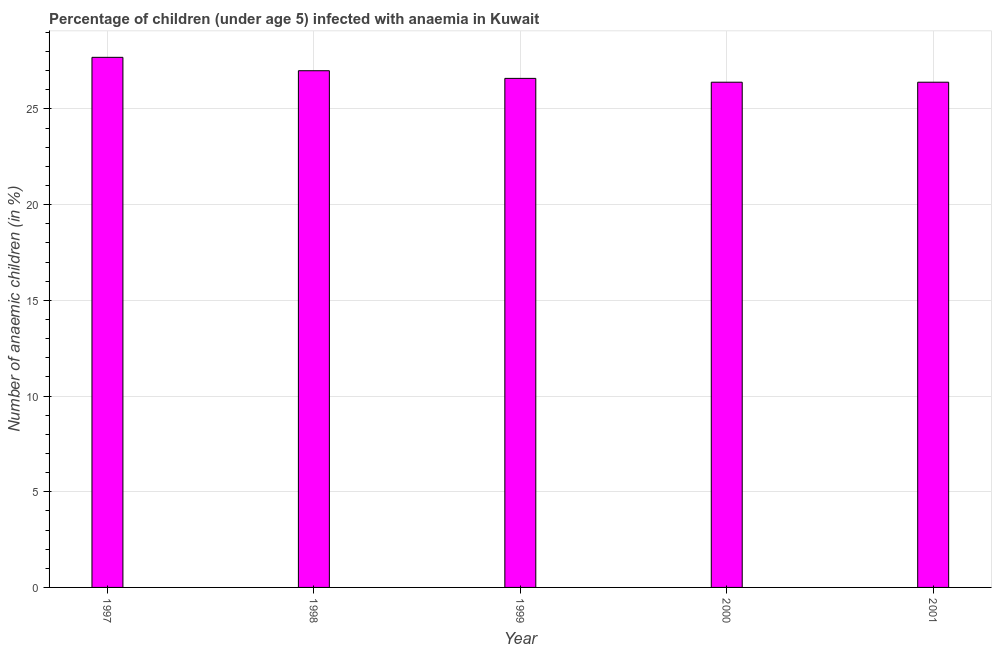Does the graph contain grids?
Give a very brief answer. Yes. What is the title of the graph?
Offer a terse response. Percentage of children (under age 5) infected with anaemia in Kuwait. What is the label or title of the Y-axis?
Your response must be concise. Number of anaemic children (in %). What is the number of anaemic children in 2000?
Offer a very short reply. 26.4. Across all years, what is the maximum number of anaemic children?
Give a very brief answer. 27.7. Across all years, what is the minimum number of anaemic children?
Your answer should be compact. 26.4. In which year was the number of anaemic children minimum?
Make the answer very short. 2000. What is the sum of the number of anaemic children?
Provide a succinct answer. 134.1. What is the difference between the number of anaemic children in 1997 and 1998?
Ensure brevity in your answer.  0.7. What is the average number of anaemic children per year?
Your answer should be compact. 26.82. What is the median number of anaemic children?
Make the answer very short. 26.6. What is the ratio of the number of anaemic children in 1997 to that in 1999?
Give a very brief answer. 1.04. Is the sum of the number of anaemic children in 1999 and 2001 greater than the maximum number of anaemic children across all years?
Keep it short and to the point. Yes. What is the difference between the highest and the lowest number of anaemic children?
Offer a very short reply. 1.3. In how many years, is the number of anaemic children greater than the average number of anaemic children taken over all years?
Keep it short and to the point. 2. How many bars are there?
Provide a succinct answer. 5. What is the difference between two consecutive major ticks on the Y-axis?
Give a very brief answer. 5. What is the Number of anaemic children (in %) in 1997?
Keep it short and to the point. 27.7. What is the Number of anaemic children (in %) of 1998?
Ensure brevity in your answer.  27. What is the Number of anaemic children (in %) of 1999?
Offer a very short reply. 26.6. What is the Number of anaemic children (in %) in 2000?
Your answer should be compact. 26.4. What is the Number of anaemic children (in %) in 2001?
Keep it short and to the point. 26.4. What is the difference between the Number of anaemic children (in %) in 1997 and 1998?
Provide a succinct answer. 0.7. What is the difference between the Number of anaemic children (in %) in 1997 and 2001?
Provide a short and direct response. 1.3. What is the difference between the Number of anaemic children (in %) in 1998 and 2000?
Offer a very short reply. 0.6. What is the difference between the Number of anaemic children (in %) in 1998 and 2001?
Make the answer very short. 0.6. What is the difference between the Number of anaemic children (in %) in 1999 and 2000?
Provide a short and direct response. 0.2. What is the difference between the Number of anaemic children (in %) in 1999 and 2001?
Offer a terse response. 0.2. What is the difference between the Number of anaemic children (in %) in 2000 and 2001?
Offer a very short reply. 0. What is the ratio of the Number of anaemic children (in %) in 1997 to that in 1999?
Keep it short and to the point. 1.04. What is the ratio of the Number of anaemic children (in %) in 1997 to that in 2000?
Provide a succinct answer. 1.05. What is the ratio of the Number of anaemic children (in %) in 1997 to that in 2001?
Ensure brevity in your answer.  1.05. What is the ratio of the Number of anaemic children (in %) in 1998 to that in 1999?
Your answer should be compact. 1.01. What is the ratio of the Number of anaemic children (in %) in 1998 to that in 2000?
Your answer should be compact. 1.02. What is the ratio of the Number of anaemic children (in %) in 1999 to that in 2000?
Offer a terse response. 1.01. What is the ratio of the Number of anaemic children (in %) in 1999 to that in 2001?
Offer a terse response. 1.01. What is the ratio of the Number of anaemic children (in %) in 2000 to that in 2001?
Your response must be concise. 1. 